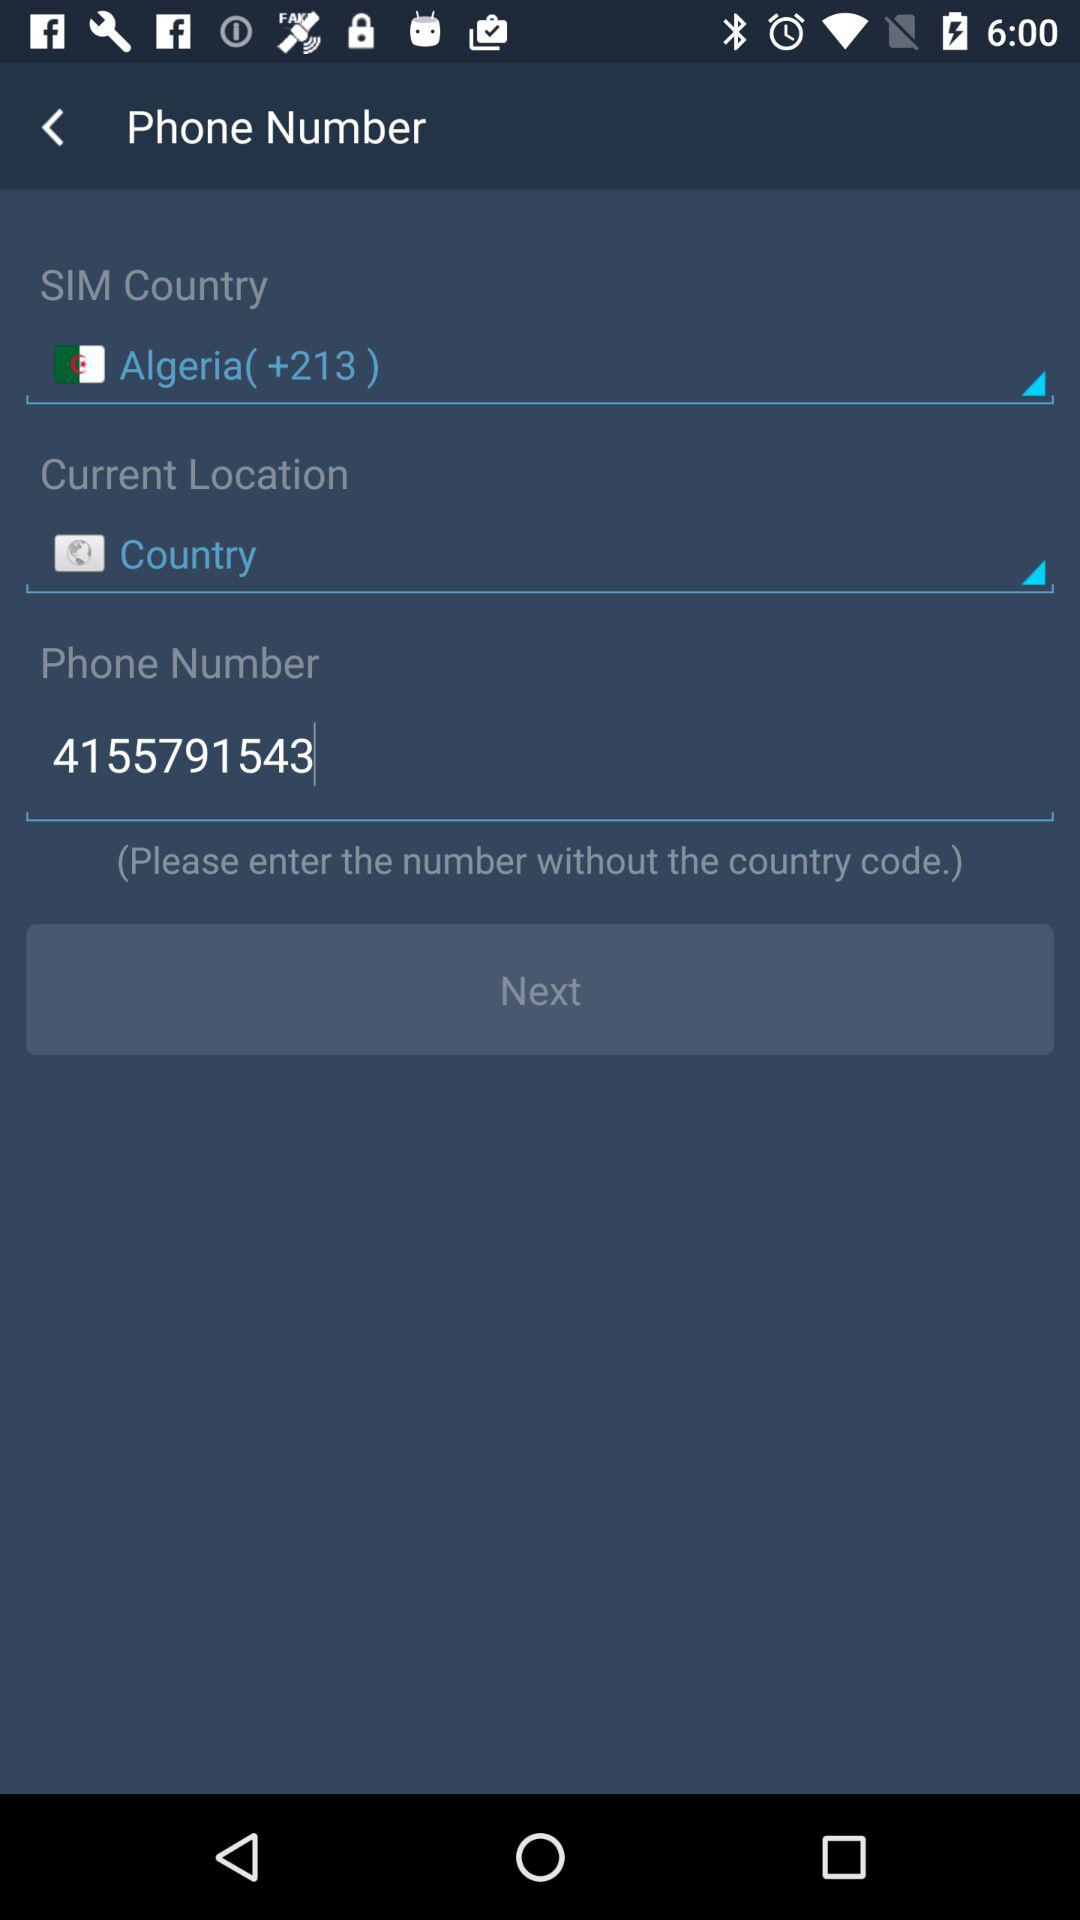What is the country code given? The given country code is +213. 